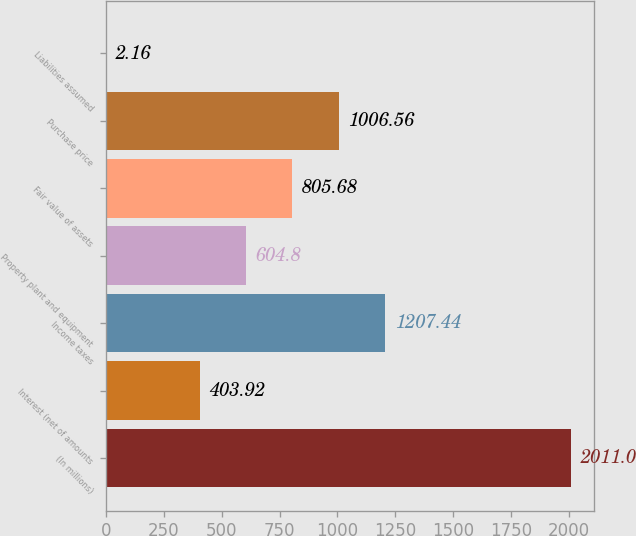Convert chart. <chart><loc_0><loc_0><loc_500><loc_500><bar_chart><fcel>(In millions)<fcel>Interest (net of amounts<fcel>Income taxes<fcel>Property plant and equipment<fcel>Fair value of assets<fcel>Purchase price<fcel>Liabilities assumed<nl><fcel>2011<fcel>403.92<fcel>1207.44<fcel>604.8<fcel>805.68<fcel>1006.56<fcel>2.16<nl></chart> 